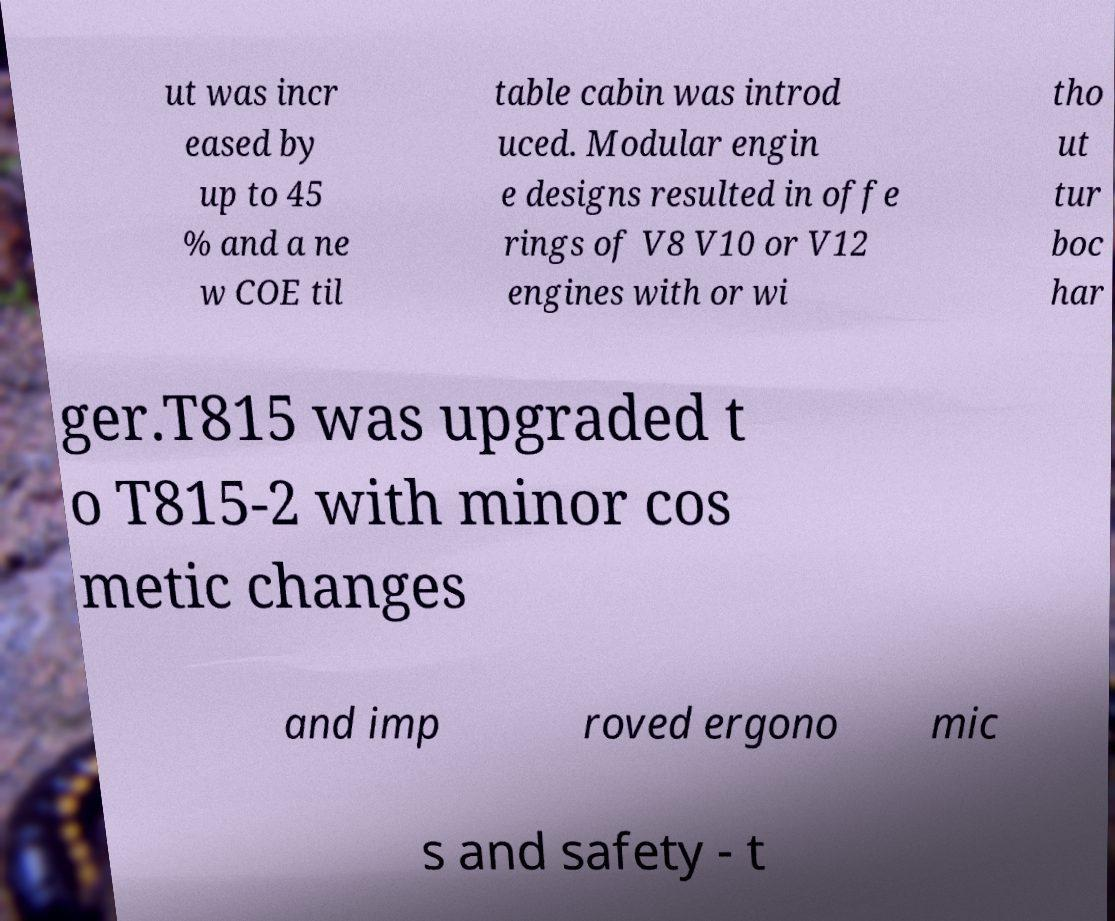Please read and relay the text visible in this image. What does it say? ut was incr eased by up to 45 % and a ne w COE til table cabin was introd uced. Modular engin e designs resulted in offe rings of V8 V10 or V12 engines with or wi tho ut tur boc har ger.T815 was upgraded t o T815-2 with minor cos metic changes and imp roved ergono mic s and safety - t 